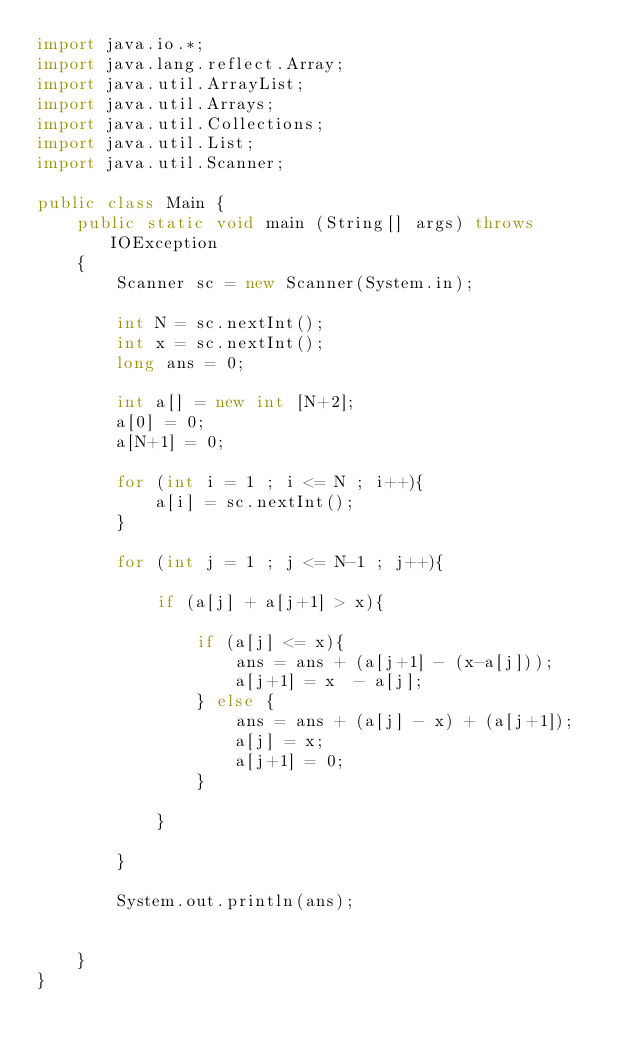<code> <loc_0><loc_0><loc_500><loc_500><_Java_>import java.io.*;
import java.lang.reflect.Array;
import java.util.ArrayList;
import java.util.Arrays;
import java.util.Collections;
import java.util.List;
import java.util.Scanner;
 
public class Main {
    public static void main (String[] args) throws IOException
    {
    	Scanner sc = new Scanner(System.in);
    
    	int N = sc.nextInt();
    	int x = sc.nextInt();
    	long ans = 0;
    	
    	int a[] = new int [N+2];
    	a[0] = 0;
    	a[N+1] = 0;
    	
    	for (int i = 1 ; i <= N ; i++){
    		a[i] = sc.nextInt();
    	}
    	
    	for (int j = 1 ; j <= N-1 ; j++){
    		
    		if (a[j] + a[j+1] > x){
    			
    			if (a[j] <= x){
    				ans = ans + (a[j+1] - (x-a[j]));
    				a[j+1] = x  - a[j];
    			} else {
    				ans = ans + (a[j] - x) + (a[j+1]);
    				a[j] = x;
    				a[j+1] = 0;
    			}
    			
    		}
    		
    	}
    	
    	System.out.println(ans);
    	
    	
    }
}
    </code> 